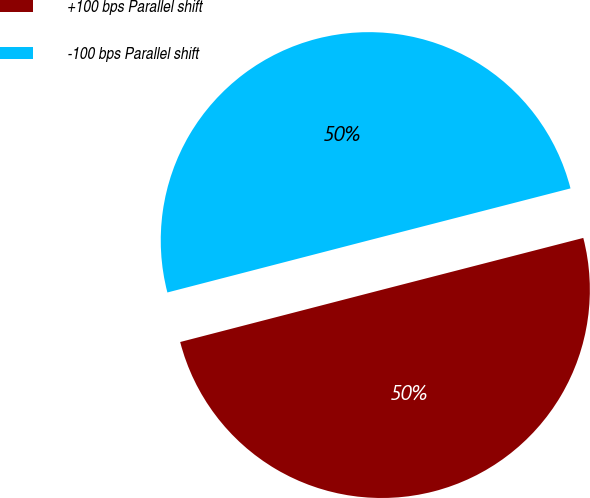Convert chart. <chart><loc_0><loc_0><loc_500><loc_500><pie_chart><fcel>+100 bps Parallel shift<fcel>-100 bps Parallel shift<nl><fcel>49.98%<fcel>50.02%<nl></chart> 